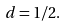Convert formula to latex. <formula><loc_0><loc_0><loc_500><loc_500>d = 1 / 2 .</formula> 